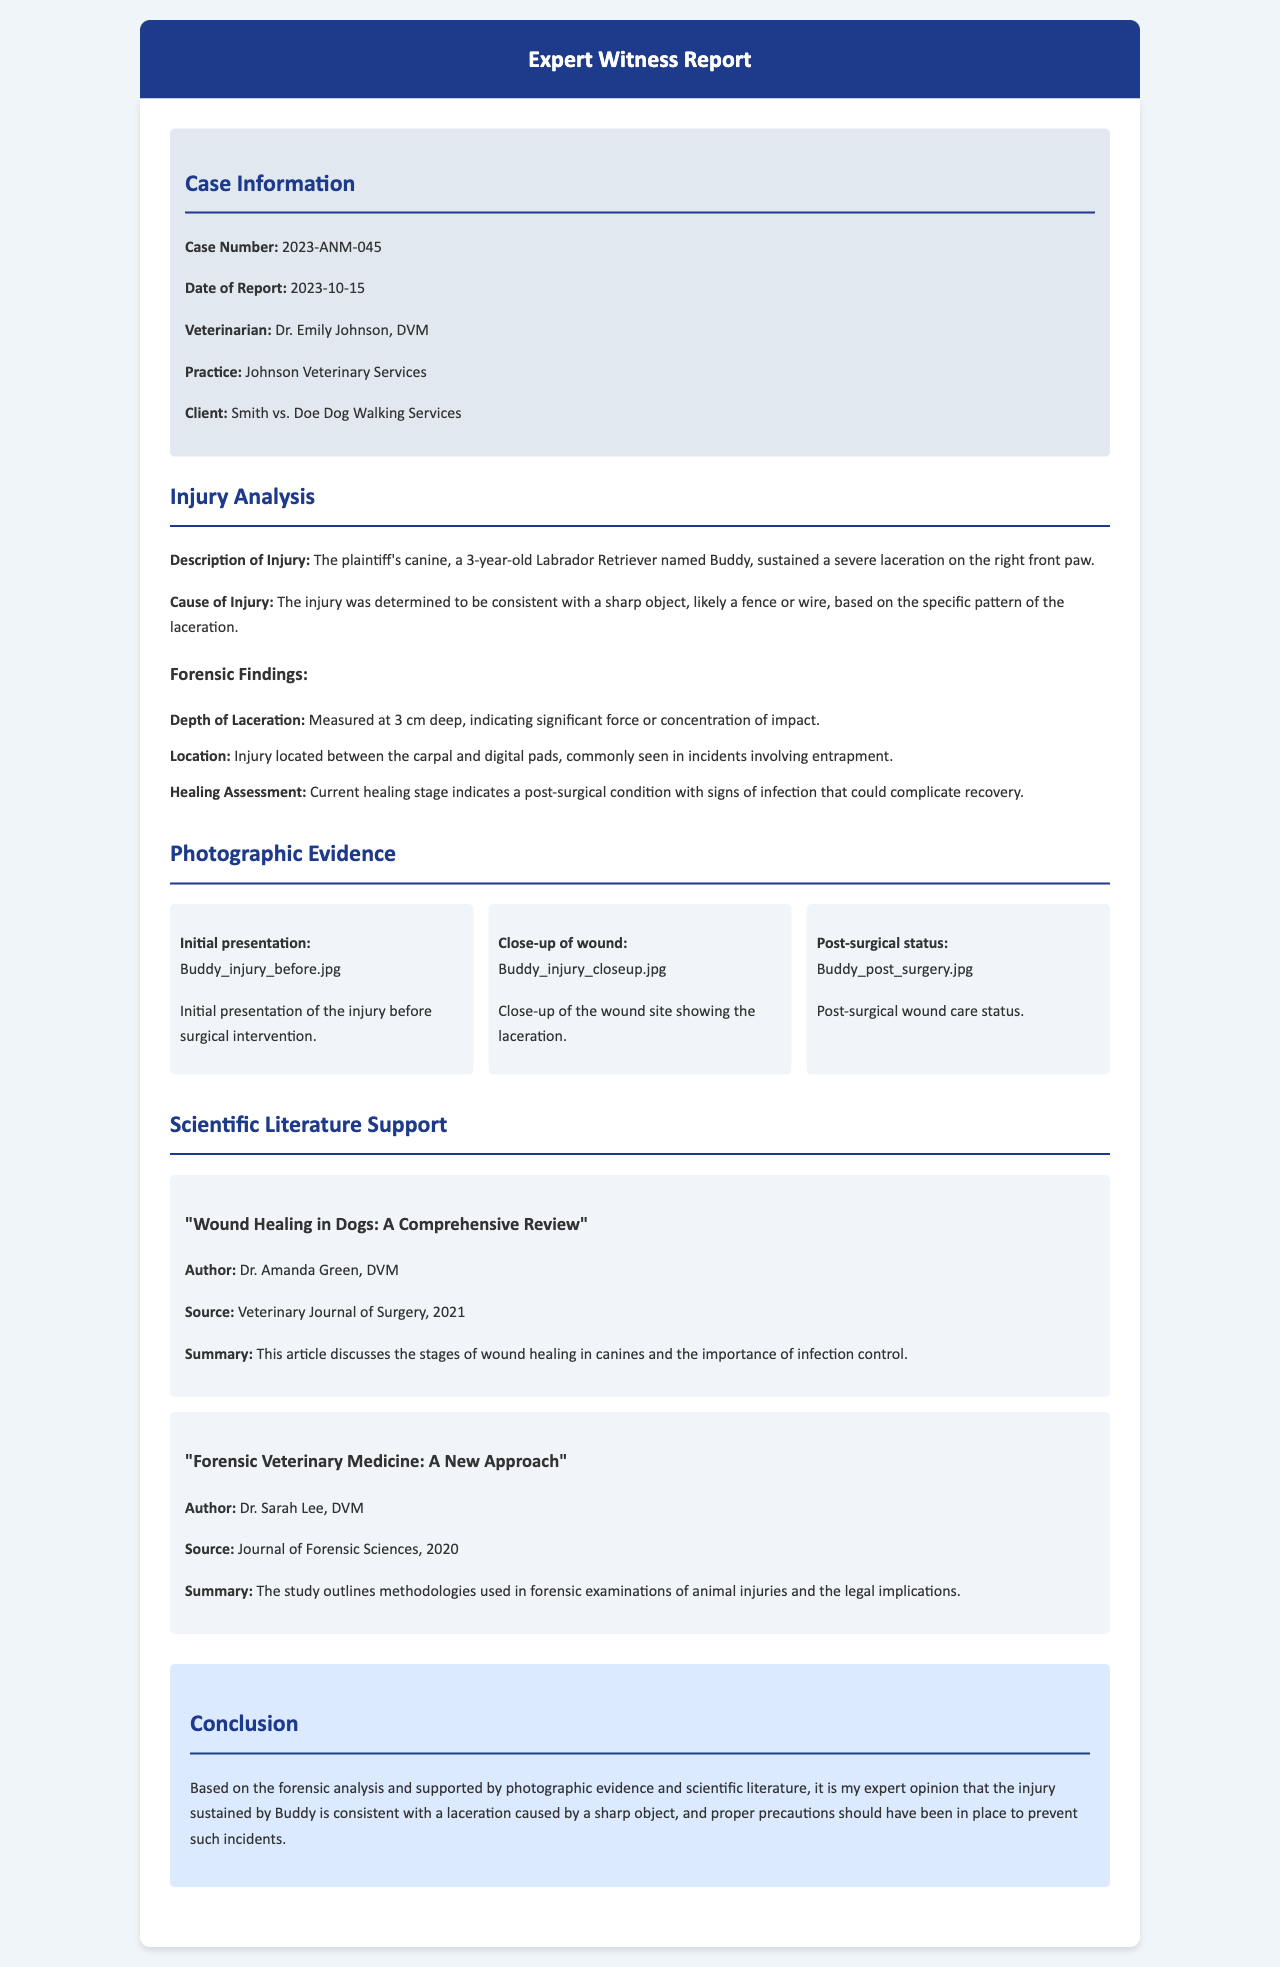What is the case number? The case number is provided in the case information section of the document.
Answer: 2023-ANM-045 Who authored the scientific article on wound healing in dogs? The author of the article is mentioned in the scientific literature section of the document.
Answer: Dr. Amanda Green, DVM What is the age of Buddy, the canine involved in the case? The age of Buddy is stated in the injury analysis section of the document.
Answer: 3 years old What caused the injury to Buddy? The cause of the injury is discussed in the injury analysis section of the document, based on forensic findings.
Answer: Sharp object What was the depth of the laceration? The depth of the laceration is specifically measured in the forensic findings within the injury analysis section.
Answer: 3 cm Which aspect was highlighted in the conclusion? The conclusion summarizes the findings discussed throughout the report concerning injury prevention.
Answer: Injury prevention What does the post-surgical status photo depict? The description of the photo in the photographic evidence section indicates what it shows.
Answer: Post-surgical wound care status How many scientific literature items are referenced? The number of literature items can be counted from the scientific literature support section.
Answer: 2 